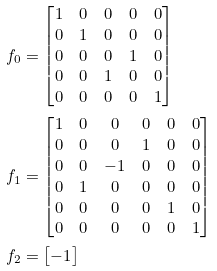Convert formula to latex. <formula><loc_0><loc_0><loc_500><loc_500>f _ { 0 } & = \begin{bmatrix} 1 & 0 & 0 & 0 & 0 \\ 0 & 1 & 0 & 0 & 0 \\ 0 & 0 & 0 & 1 & 0 \\ 0 & 0 & 1 & 0 & 0 \\ 0 & 0 & 0 & 0 & 1 \end{bmatrix} \\ f _ { 1 } & = \begin{bmatrix} 1 & 0 & 0 & 0 & 0 & 0 \\ 0 & 0 & 0 & 1 & 0 & 0 \\ 0 & 0 & - 1 & 0 & 0 & 0 \\ 0 & 1 & 0 & 0 & 0 & 0 \\ 0 & 0 & 0 & 0 & 1 & 0 \\ 0 & 0 & 0 & 0 & 0 & 1 \end{bmatrix} \\ f _ { 2 } & = \begin{bmatrix} - 1 \end{bmatrix}</formula> 